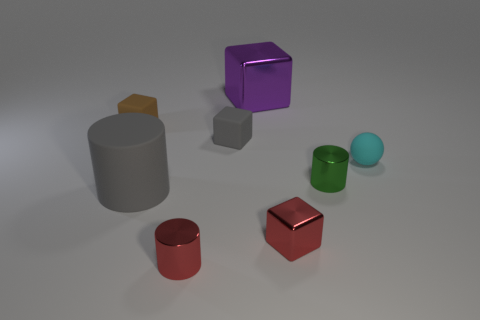Add 1 purple metallic objects. How many objects exist? 9 Subtract all small metallic cylinders. How many cylinders are left? 1 Subtract all gray blocks. How many blocks are left? 3 Subtract all balls. How many objects are left? 7 Subtract all cyan cylinders. Subtract all gray spheres. How many cylinders are left? 3 Add 1 purple metal blocks. How many purple metal blocks are left? 2 Add 5 gray cylinders. How many gray cylinders exist? 6 Subtract 0 green spheres. How many objects are left? 8 Subtract all large yellow rubber cylinders. Subtract all purple things. How many objects are left? 7 